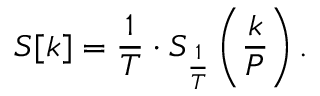<formula> <loc_0><loc_0><loc_500><loc_500>S [ k ] = { \frac { 1 } { T } } \cdot S _ { \frac { 1 } { T } } \left ( { \frac { k } { P } } \right ) .</formula> 